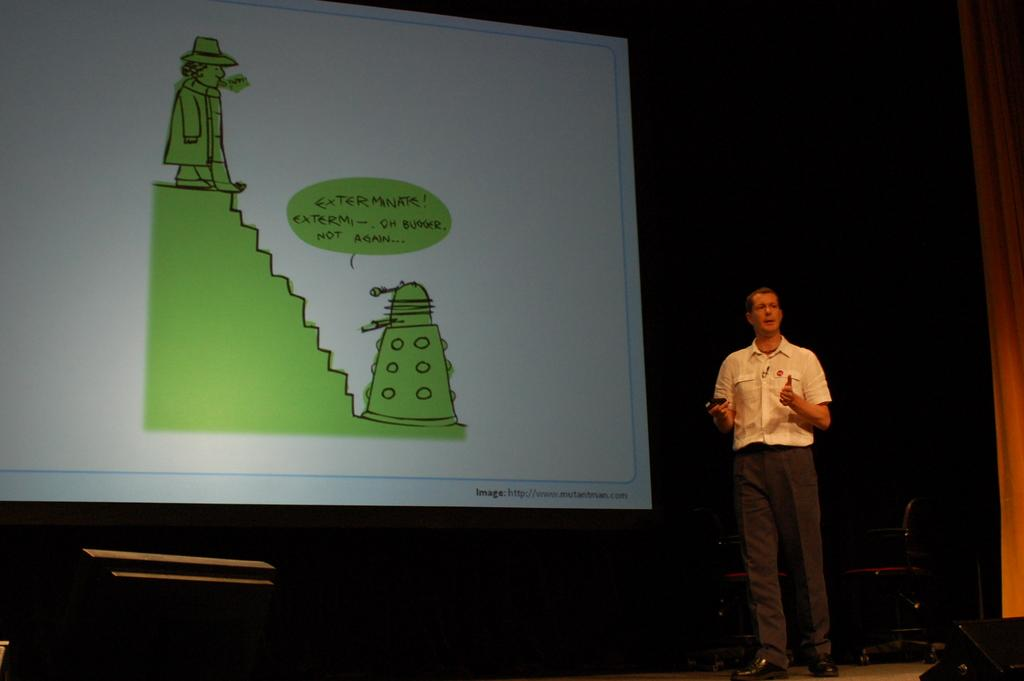What is the main subject of the image? There is a person standing in the image. Can you describe the person's attire? The person is wearing a white and black color dress. What can be seen in the background of the image? There is a projection screen in the background of the image. What type of wood can be seen on the side of the person in the image? There is no wood visible on the person or in the image. Can you describe the bee that is flying around the person in the image? There are no bees present in the image. 